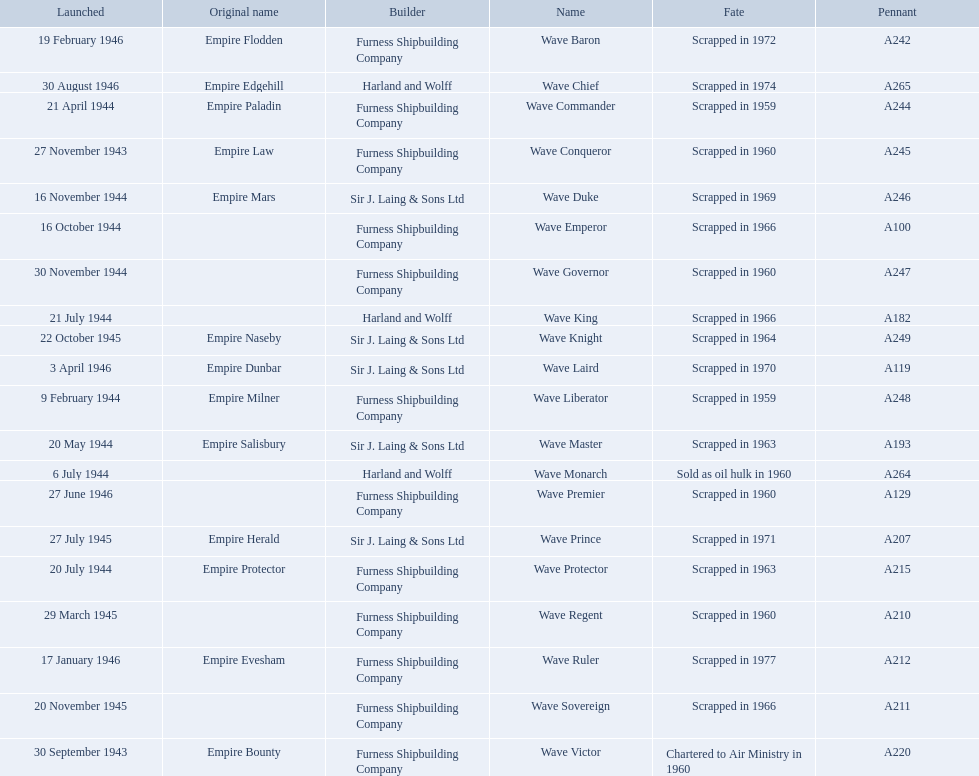What year was the wave victor launched? 30 September 1943. What other ship was launched in 1943? Wave Conqueror. 